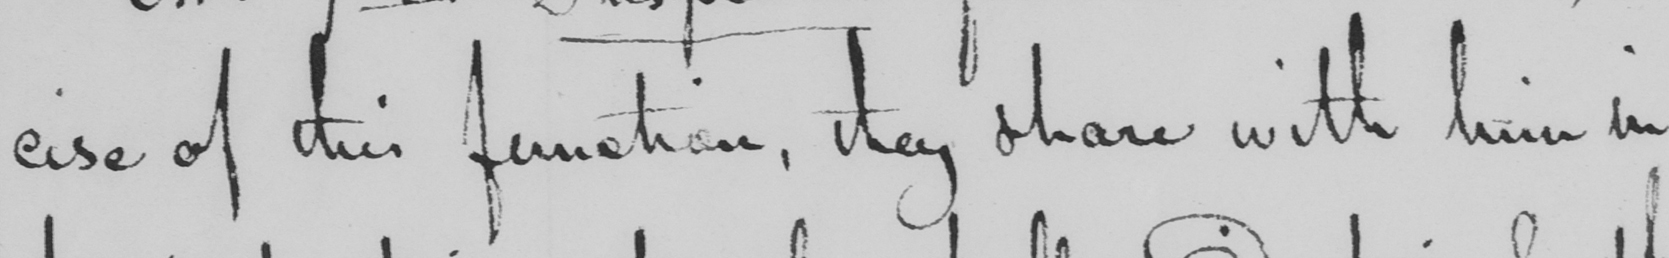Please provide the text content of this handwritten line. cise of this function , they share with him in 